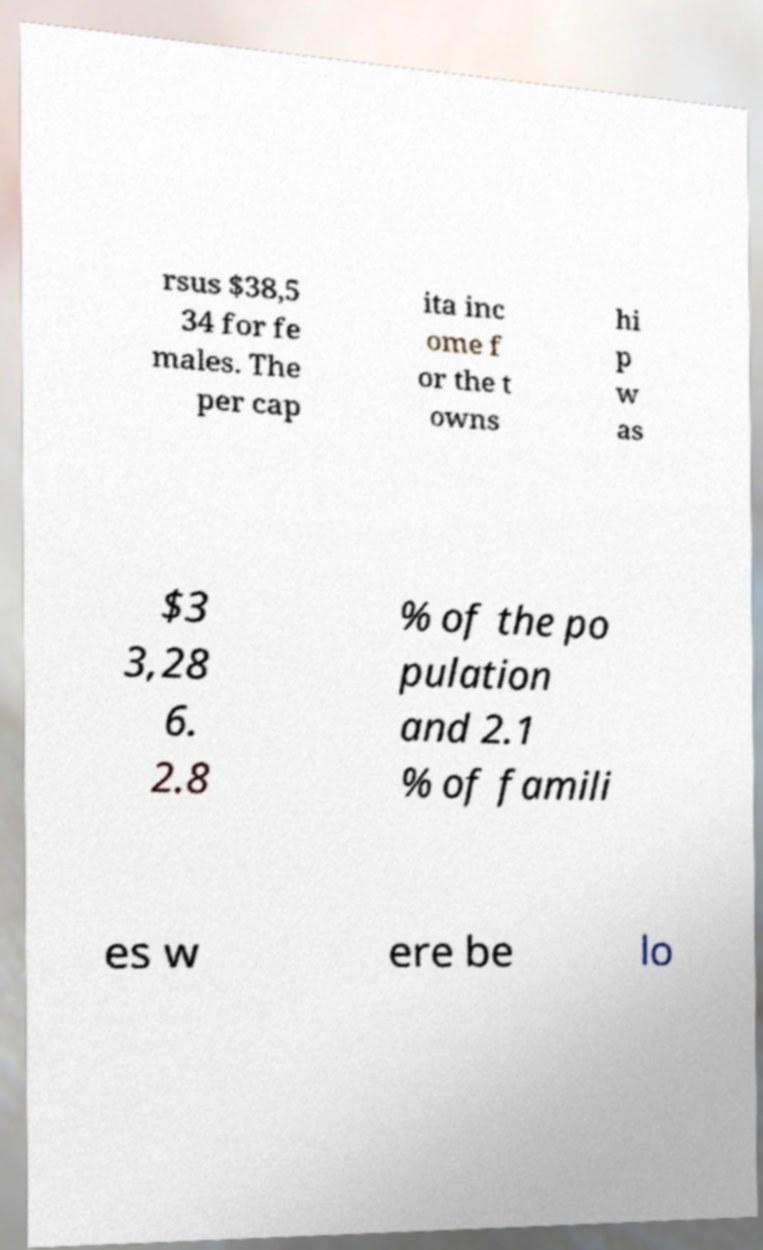Please read and relay the text visible in this image. What does it say? rsus $38,5 34 for fe males. The per cap ita inc ome f or the t owns hi p w as $3 3,28 6. 2.8 % of the po pulation and 2.1 % of famili es w ere be lo 